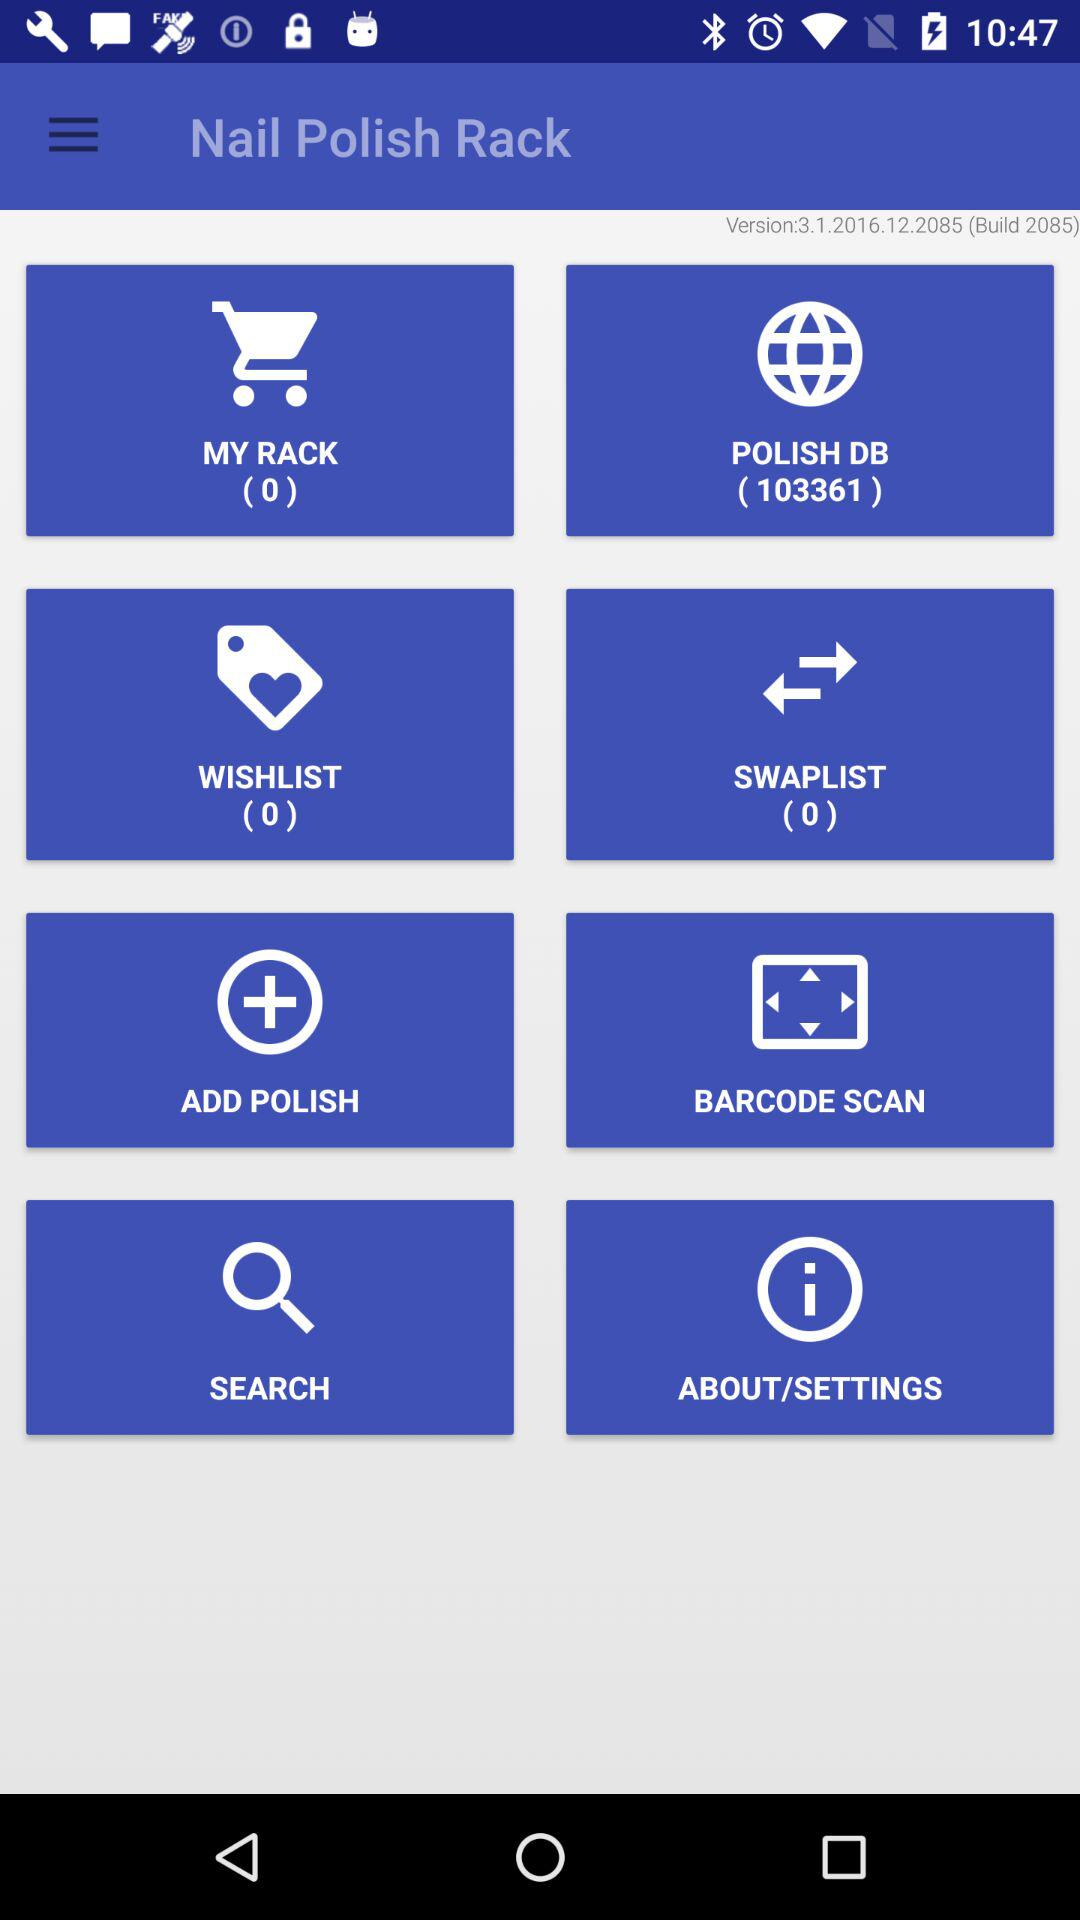What is the version of the application? The version is 3.1.2016.12.2085. 